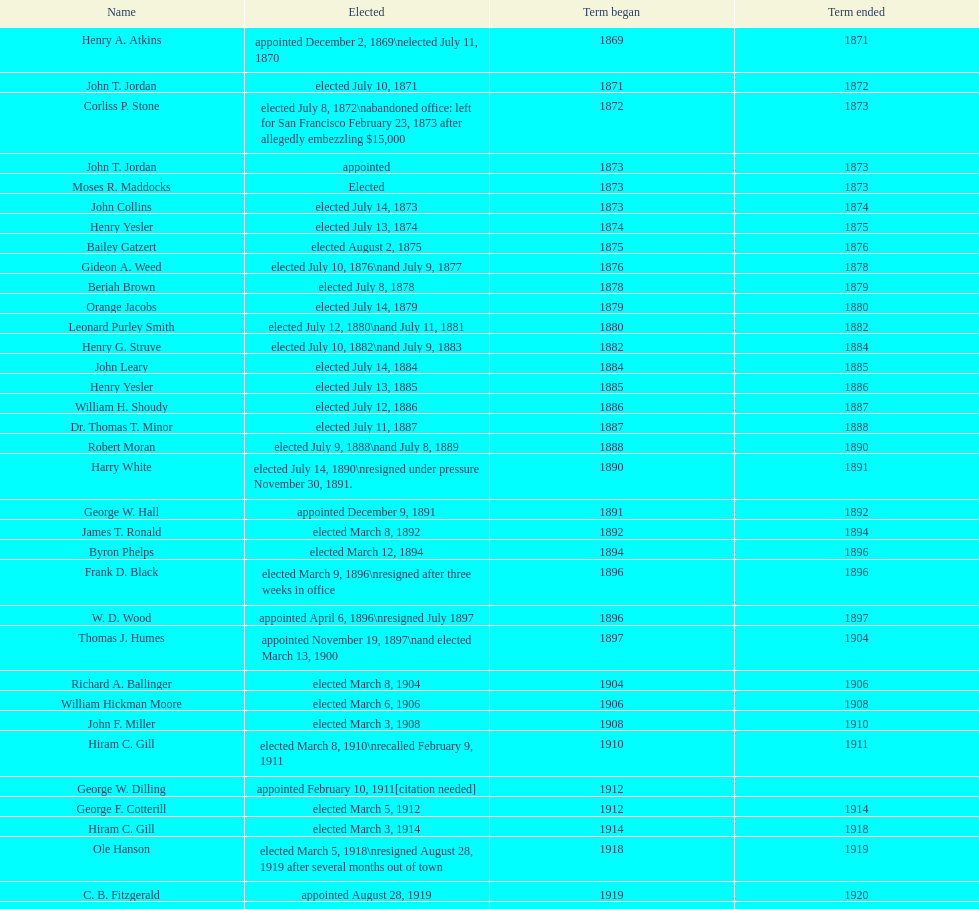Which mayor seattle, washington resigned after only three weeks in office in 1896? Frank D. Black. 